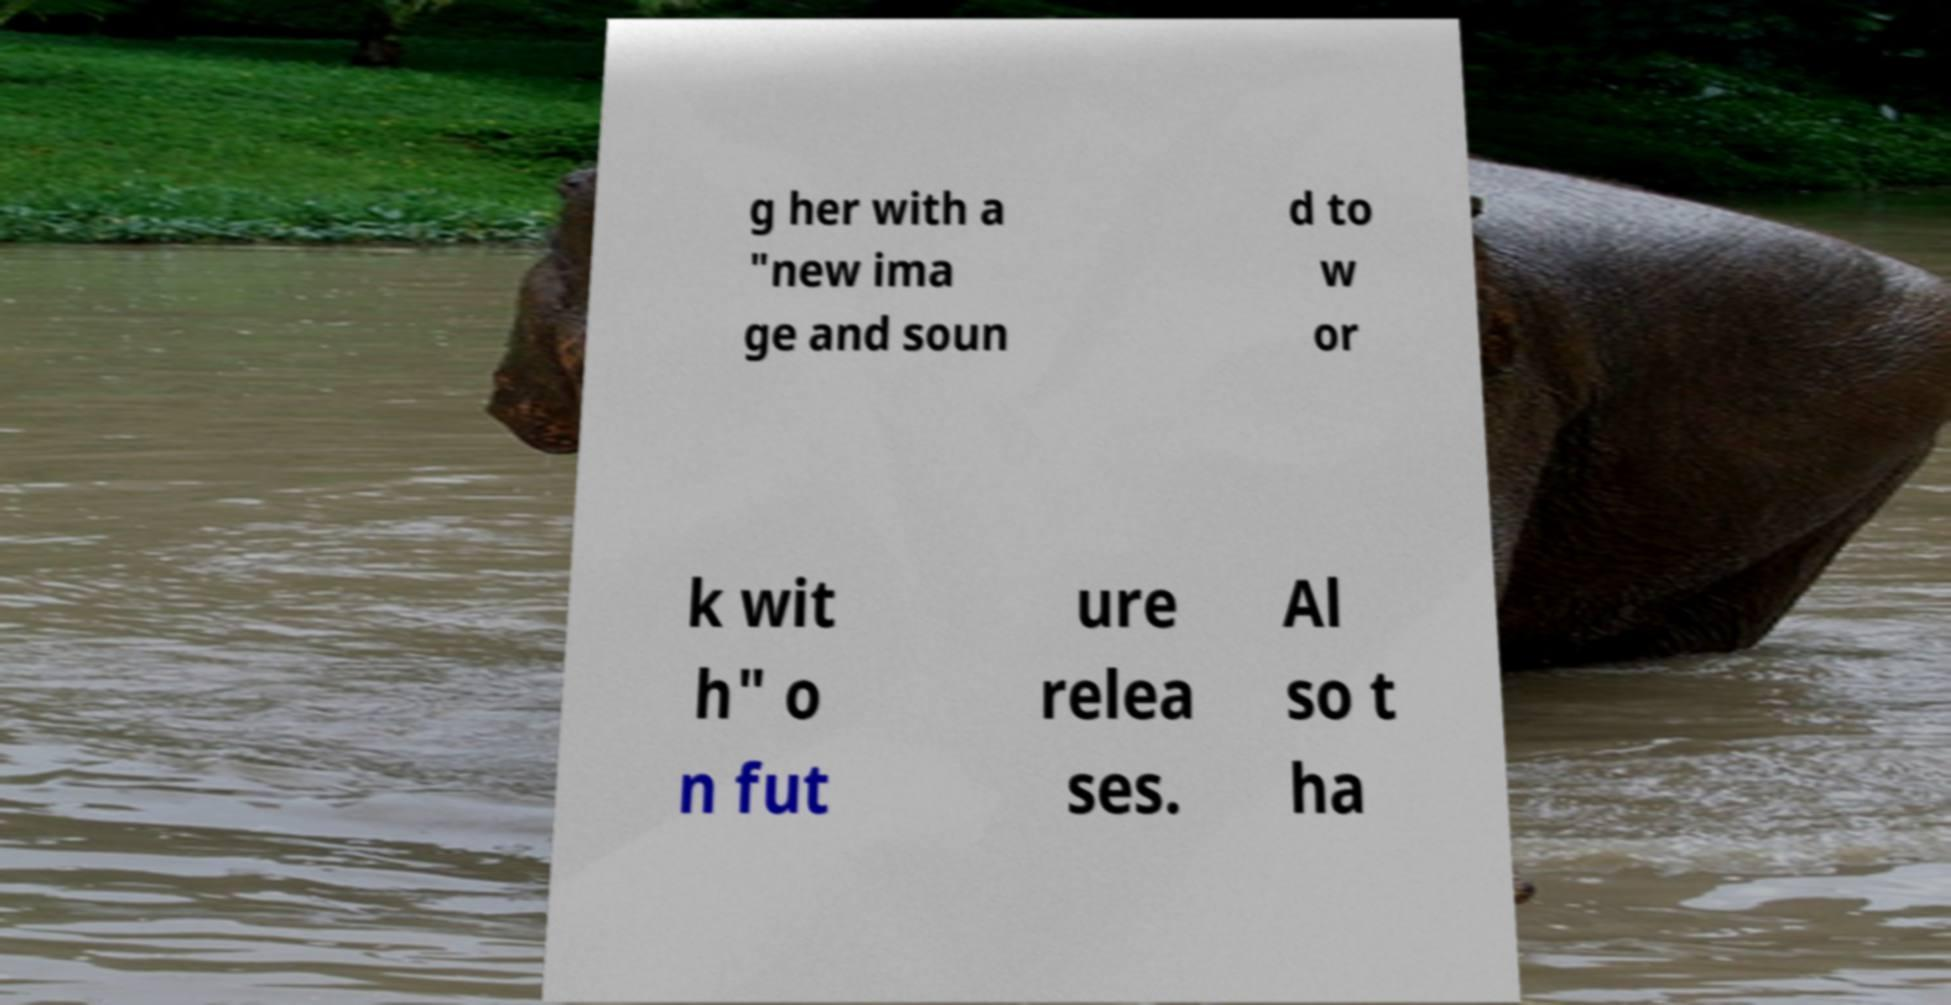For documentation purposes, I need the text within this image transcribed. Could you provide that? g her with a "new ima ge and soun d to w or k wit h" o n fut ure relea ses. Al so t ha 